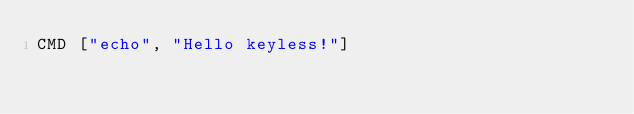<code> <loc_0><loc_0><loc_500><loc_500><_Dockerfile_>CMD ["echo", "Hello keyless!"]
</code> 